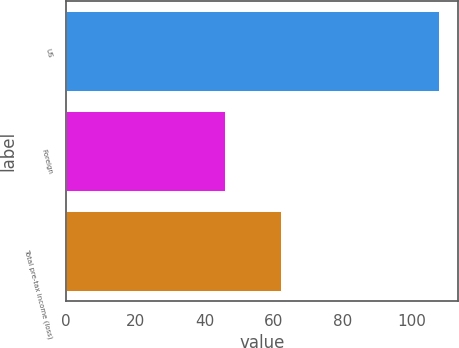Convert chart. <chart><loc_0><loc_0><loc_500><loc_500><bar_chart><fcel>US<fcel>Foreign<fcel>Total pre-tax income (loss)<nl><fcel>108<fcel>46<fcel>62<nl></chart> 